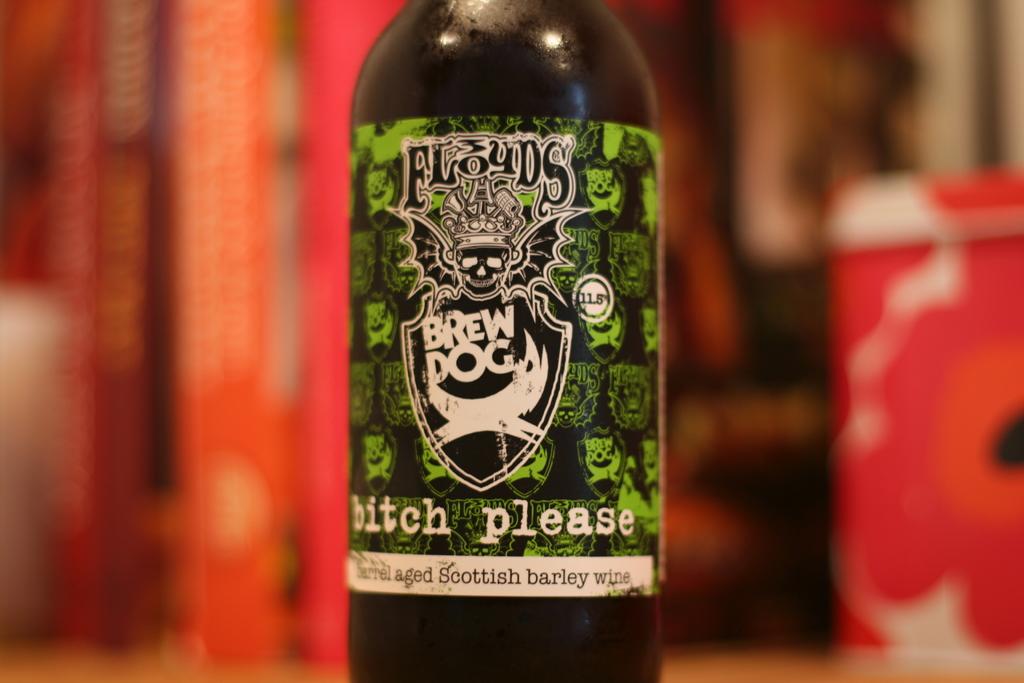What country does the beer come from?
Your response must be concise. Scotland. 